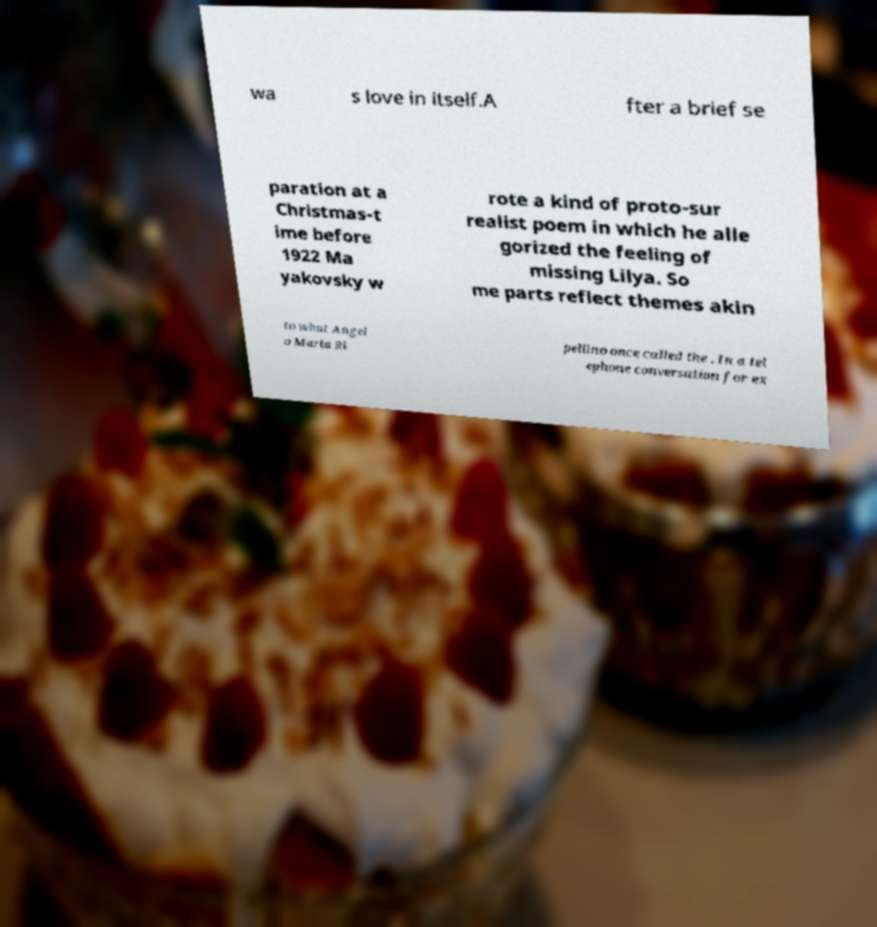Could you extract and type out the text from this image? wa s love in itself.A fter a brief se paration at a Christmas-t ime before 1922 Ma yakovsky w rote a kind of proto-sur realist poem in which he alle gorized the feeling of missing Lilya. So me parts reflect themes akin to what Angel o Maria Ri pellino once called the . In a tel ephone conversation for ex 